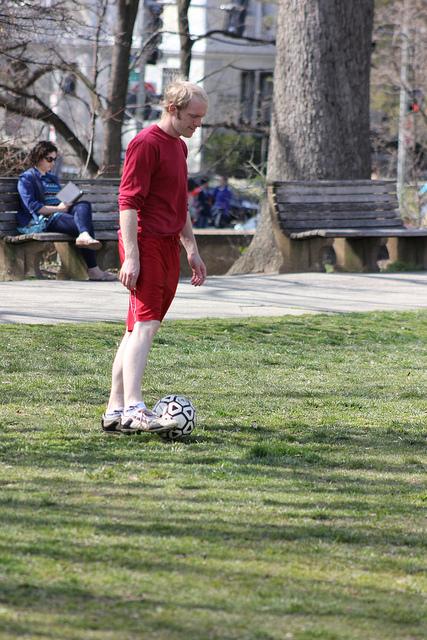What color is the man wearing?
Be succinct. Red. What game is this man playing?
Keep it brief. Soccer. How many benches are there?
Concise answer only. 2. 